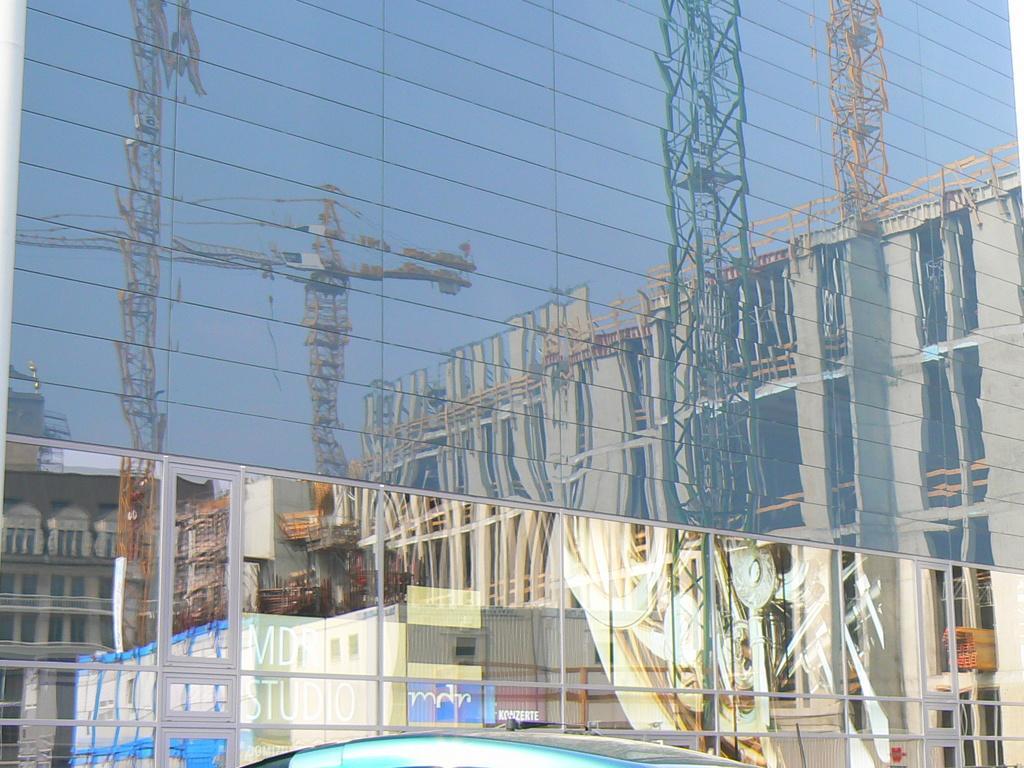Describe this image in one or two sentences. This picture is clicked outside the city. At the bottom of the picture, we see buildings and at the top of the picture we see a glass building in which we can see buildings and cranes. 